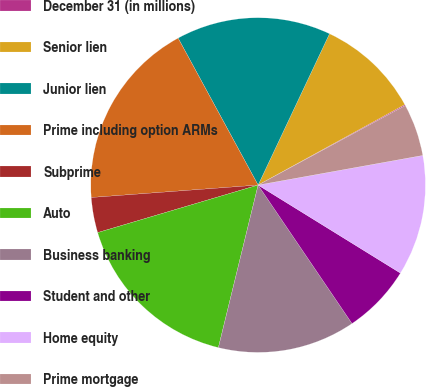<chart> <loc_0><loc_0><loc_500><loc_500><pie_chart><fcel>December 31 (in millions)<fcel>Senior lien<fcel>Junior lien<fcel>Prime including option ARMs<fcel>Subprime<fcel>Auto<fcel>Business banking<fcel>Student and other<fcel>Home equity<fcel>Prime mortgage<nl><fcel>0.1%<fcel>10.0%<fcel>14.95%<fcel>18.25%<fcel>3.4%<fcel>16.6%<fcel>13.3%<fcel>6.7%<fcel>11.65%<fcel>5.05%<nl></chart> 